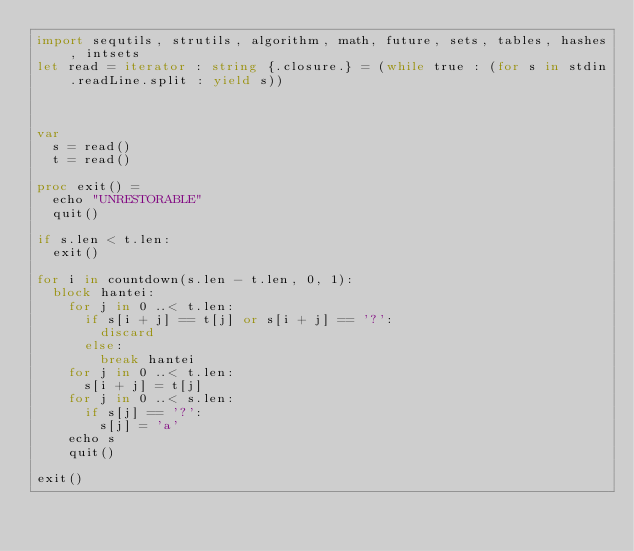Convert code to text. <code><loc_0><loc_0><loc_500><loc_500><_Nim_>import sequtils, strutils, algorithm, math, future, sets, tables, hashes, intsets
let read = iterator : string {.closure.} = (while true : (for s in stdin.readLine.split : yield s))



var
  s = read()
  t = read()

proc exit() = 
  echo "UNRESTORABLE"
  quit()

if s.len < t.len:
  exit()

for i in countdown(s.len - t.len, 0, 1):
  block hantei:
    for j in 0 ..< t.len:
      if s[i + j] == t[j] or s[i + j] == '?':
        discard
      else:
        break hantei
    for j in 0 ..< t.len:
      s[i + j] = t[j]
    for j in 0 ..< s.len:
      if s[j] == '?':
        s[j] = 'a'
    echo s
    quit()

exit()</code> 